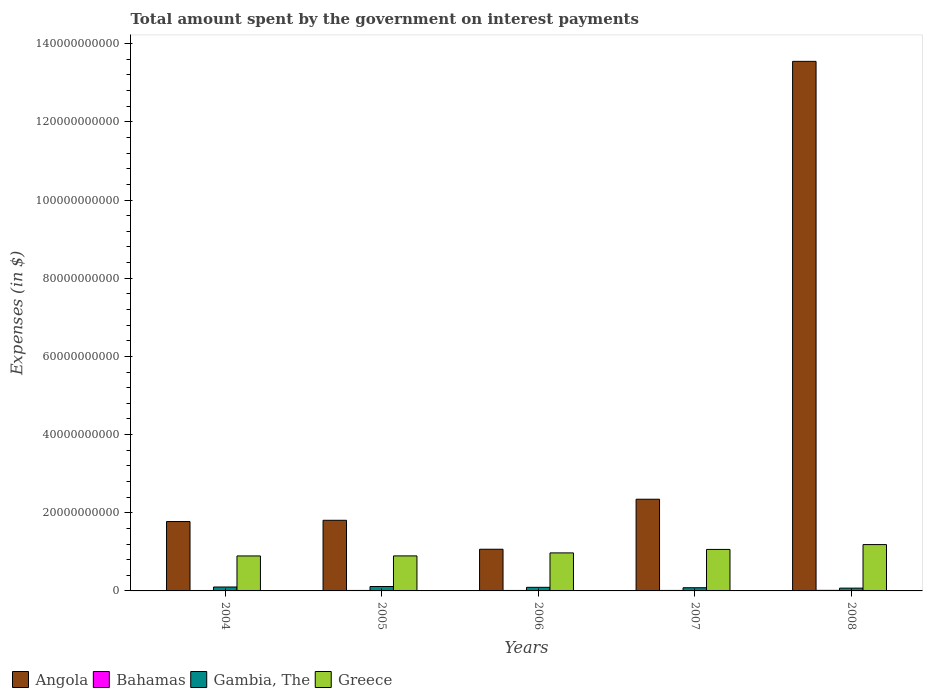How many different coloured bars are there?
Make the answer very short. 4. Are the number of bars per tick equal to the number of legend labels?
Give a very brief answer. Yes. Are the number of bars on each tick of the X-axis equal?
Keep it short and to the point. Yes. How many bars are there on the 2nd tick from the left?
Make the answer very short. 4. What is the amount spent on interest payments by the government in Angola in 2007?
Provide a succinct answer. 2.35e+1. Across all years, what is the maximum amount spent on interest payments by the government in Bahamas?
Your response must be concise. 1.43e+08. Across all years, what is the minimum amount spent on interest payments by the government in Greece?
Offer a very short reply. 8.95e+09. In which year was the amount spent on interest payments by the government in Gambia, The maximum?
Your answer should be very brief. 2005. What is the total amount spent on interest payments by the government in Greece in the graph?
Your response must be concise. 5.01e+1. What is the difference between the amount spent on interest payments by the government in Angola in 2006 and that in 2008?
Give a very brief answer. -1.25e+11. What is the difference between the amount spent on interest payments by the government in Gambia, The in 2008 and the amount spent on interest payments by the government in Greece in 2007?
Offer a terse response. -9.90e+09. What is the average amount spent on interest payments by the government in Bahamas per year?
Keep it short and to the point. 1.24e+08. In the year 2006, what is the difference between the amount spent on interest payments by the government in Gambia, The and amount spent on interest payments by the government in Greece?
Your response must be concise. -8.81e+09. In how many years, is the amount spent on interest payments by the government in Bahamas greater than 100000000000 $?
Provide a succinct answer. 0. What is the ratio of the amount spent on interest payments by the government in Bahamas in 2005 to that in 2006?
Your answer should be very brief. 1.04. Is the amount spent on interest payments by the government in Greece in 2004 less than that in 2005?
Your answer should be very brief. Yes. Is the difference between the amount spent on interest payments by the government in Gambia, The in 2005 and 2006 greater than the difference between the amount spent on interest payments by the government in Greece in 2005 and 2006?
Keep it short and to the point. Yes. What is the difference between the highest and the second highest amount spent on interest payments by the government in Gambia, The?
Make the answer very short. 1.28e+08. What is the difference between the highest and the lowest amount spent on interest payments by the government in Angola?
Ensure brevity in your answer.  1.25e+11. In how many years, is the amount spent on interest payments by the government in Greece greater than the average amount spent on interest payments by the government in Greece taken over all years?
Provide a succinct answer. 2. Is the sum of the amount spent on interest payments by the government in Bahamas in 2004 and 2006 greater than the maximum amount spent on interest payments by the government in Greece across all years?
Your answer should be very brief. No. Is it the case that in every year, the sum of the amount spent on interest payments by the government in Bahamas and amount spent on interest payments by the government in Greece is greater than the sum of amount spent on interest payments by the government in Gambia, The and amount spent on interest payments by the government in Angola?
Your answer should be very brief. No. What does the 2nd bar from the left in 2005 represents?
Give a very brief answer. Bahamas. What does the 1st bar from the right in 2005 represents?
Ensure brevity in your answer.  Greece. How many bars are there?
Provide a short and direct response. 20. Are all the bars in the graph horizontal?
Offer a terse response. No. What is the difference between two consecutive major ticks on the Y-axis?
Keep it short and to the point. 2.00e+1. Does the graph contain any zero values?
Provide a short and direct response. No. Does the graph contain grids?
Give a very brief answer. No. How many legend labels are there?
Your answer should be compact. 4. What is the title of the graph?
Offer a terse response. Total amount spent by the government on interest payments. Does "Ukraine" appear as one of the legend labels in the graph?
Keep it short and to the point. No. What is the label or title of the X-axis?
Your answer should be compact. Years. What is the label or title of the Y-axis?
Your answer should be very brief. Expenses (in $). What is the Expenses (in $) in Angola in 2004?
Provide a succinct answer. 1.78e+1. What is the Expenses (in $) in Bahamas in 2004?
Your response must be concise. 1.14e+08. What is the Expenses (in $) in Gambia, The in 2004?
Your response must be concise. 1.00e+09. What is the Expenses (in $) in Greece in 2004?
Ensure brevity in your answer.  8.95e+09. What is the Expenses (in $) of Angola in 2005?
Ensure brevity in your answer.  1.81e+1. What is the Expenses (in $) of Bahamas in 2005?
Offer a terse response. 1.21e+08. What is the Expenses (in $) in Gambia, The in 2005?
Your response must be concise. 1.13e+09. What is the Expenses (in $) of Greece in 2005?
Provide a succinct answer. 8.96e+09. What is the Expenses (in $) in Angola in 2006?
Your response must be concise. 1.07e+1. What is the Expenses (in $) in Bahamas in 2006?
Ensure brevity in your answer.  1.17e+08. What is the Expenses (in $) of Gambia, The in 2006?
Make the answer very short. 9.21e+08. What is the Expenses (in $) of Greece in 2006?
Your answer should be very brief. 9.73e+09. What is the Expenses (in $) in Angola in 2007?
Provide a succinct answer. 2.35e+1. What is the Expenses (in $) of Bahamas in 2007?
Provide a succinct answer. 1.27e+08. What is the Expenses (in $) in Gambia, The in 2007?
Your response must be concise. 8.15e+08. What is the Expenses (in $) in Greece in 2007?
Ensure brevity in your answer.  1.06e+1. What is the Expenses (in $) in Angola in 2008?
Give a very brief answer. 1.35e+11. What is the Expenses (in $) of Bahamas in 2008?
Ensure brevity in your answer.  1.43e+08. What is the Expenses (in $) in Gambia, The in 2008?
Provide a short and direct response. 7.13e+08. What is the Expenses (in $) in Greece in 2008?
Your answer should be very brief. 1.19e+1. Across all years, what is the maximum Expenses (in $) in Angola?
Your answer should be very brief. 1.35e+11. Across all years, what is the maximum Expenses (in $) of Bahamas?
Your response must be concise. 1.43e+08. Across all years, what is the maximum Expenses (in $) of Gambia, The?
Make the answer very short. 1.13e+09. Across all years, what is the maximum Expenses (in $) in Greece?
Give a very brief answer. 1.19e+1. Across all years, what is the minimum Expenses (in $) in Angola?
Your answer should be compact. 1.07e+1. Across all years, what is the minimum Expenses (in $) in Bahamas?
Make the answer very short. 1.14e+08. Across all years, what is the minimum Expenses (in $) of Gambia, The?
Keep it short and to the point. 7.13e+08. Across all years, what is the minimum Expenses (in $) of Greece?
Offer a very short reply. 8.95e+09. What is the total Expenses (in $) in Angola in the graph?
Offer a very short reply. 2.05e+11. What is the total Expenses (in $) in Bahamas in the graph?
Ensure brevity in your answer.  6.22e+08. What is the total Expenses (in $) in Gambia, The in the graph?
Offer a terse response. 4.58e+09. What is the total Expenses (in $) in Greece in the graph?
Your answer should be compact. 5.01e+1. What is the difference between the Expenses (in $) of Angola in 2004 and that in 2005?
Provide a succinct answer. -3.18e+08. What is the difference between the Expenses (in $) of Bahamas in 2004 and that in 2005?
Provide a short and direct response. -7.31e+06. What is the difference between the Expenses (in $) in Gambia, The in 2004 and that in 2005?
Keep it short and to the point. -1.28e+08. What is the difference between the Expenses (in $) of Greece in 2004 and that in 2005?
Provide a succinct answer. -1.20e+07. What is the difference between the Expenses (in $) of Angola in 2004 and that in 2006?
Provide a succinct answer. 7.09e+09. What is the difference between the Expenses (in $) of Bahamas in 2004 and that in 2006?
Provide a succinct answer. -2.63e+06. What is the difference between the Expenses (in $) in Gambia, The in 2004 and that in 2006?
Provide a succinct answer. 8.17e+07. What is the difference between the Expenses (in $) of Greece in 2004 and that in 2006?
Provide a succinct answer. -7.78e+08. What is the difference between the Expenses (in $) of Angola in 2004 and that in 2007?
Offer a very short reply. -5.71e+09. What is the difference between the Expenses (in $) in Bahamas in 2004 and that in 2007?
Give a very brief answer. -1.32e+07. What is the difference between the Expenses (in $) of Gambia, The in 2004 and that in 2007?
Your response must be concise. 1.88e+08. What is the difference between the Expenses (in $) in Greece in 2004 and that in 2007?
Provide a succinct answer. -1.66e+09. What is the difference between the Expenses (in $) in Angola in 2004 and that in 2008?
Provide a short and direct response. -1.18e+11. What is the difference between the Expenses (in $) of Bahamas in 2004 and that in 2008?
Your answer should be compact. -2.92e+07. What is the difference between the Expenses (in $) in Gambia, The in 2004 and that in 2008?
Your answer should be compact. 2.90e+08. What is the difference between the Expenses (in $) in Greece in 2004 and that in 2008?
Keep it short and to the point. -2.90e+09. What is the difference between the Expenses (in $) of Angola in 2005 and that in 2006?
Give a very brief answer. 7.40e+09. What is the difference between the Expenses (in $) in Bahamas in 2005 and that in 2006?
Offer a terse response. 4.67e+06. What is the difference between the Expenses (in $) of Gambia, The in 2005 and that in 2006?
Your response must be concise. 2.10e+08. What is the difference between the Expenses (in $) of Greece in 2005 and that in 2006?
Offer a terse response. -7.66e+08. What is the difference between the Expenses (in $) of Angola in 2005 and that in 2007?
Make the answer very short. -5.39e+09. What is the difference between the Expenses (in $) of Bahamas in 2005 and that in 2007?
Your answer should be compact. -5.92e+06. What is the difference between the Expenses (in $) of Gambia, The in 2005 and that in 2007?
Keep it short and to the point. 3.16e+08. What is the difference between the Expenses (in $) of Greece in 2005 and that in 2007?
Make the answer very short. -1.65e+09. What is the difference between the Expenses (in $) in Angola in 2005 and that in 2008?
Provide a short and direct response. -1.17e+11. What is the difference between the Expenses (in $) in Bahamas in 2005 and that in 2008?
Offer a terse response. -2.19e+07. What is the difference between the Expenses (in $) in Gambia, The in 2005 and that in 2008?
Offer a terse response. 4.18e+08. What is the difference between the Expenses (in $) of Greece in 2005 and that in 2008?
Provide a succinct answer. -2.89e+09. What is the difference between the Expenses (in $) in Angola in 2006 and that in 2007?
Ensure brevity in your answer.  -1.28e+1. What is the difference between the Expenses (in $) in Bahamas in 2006 and that in 2007?
Offer a very short reply. -1.06e+07. What is the difference between the Expenses (in $) of Gambia, The in 2006 and that in 2007?
Your answer should be very brief. 1.06e+08. What is the difference between the Expenses (in $) of Greece in 2006 and that in 2007?
Provide a succinct answer. -8.87e+08. What is the difference between the Expenses (in $) of Angola in 2006 and that in 2008?
Your answer should be compact. -1.25e+11. What is the difference between the Expenses (in $) in Bahamas in 2006 and that in 2008?
Your answer should be compact. -2.66e+07. What is the difference between the Expenses (in $) of Gambia, The in 2006 and that in 2008?
Your response must be concise. 2.08e+08. What is the difference between the Expenses (in $) in Greece in 2006 and that in 2008?
Your answer should be very brief. -2.13e+09. What is the difference between the Expenses (in $) of Angola in 2007 and that in 2008?
Your response must be concise. -1.12e+11. What is the difference between the Expenses (in $) of Bahamas in 2007 and that in 2008?
Provide a succinct answer. -1.60e+07. What is the difference between the Expenses (in $) in Gambia, The in 2007 and that in 2008?
Give a very brief answer. 1.02e+08. What is the difference between the Expenses (in $) of Greece in 2007 and that in 2008?
Give a very brief answer. -1.24e+09. What is the difference between the Expenses (in $) of Angola in 2004 and the Expenses (in $) of Bahamas in 2005?
Give a very brief answer. 1.76e+1. What is the difference between the Expenses (in $) of Angola in 2004 and the Expenses (in $) of Gambia, The in 2005?
Keep it short and to the point. 1.66e+1. What is the difference between the Expenses (in $) of Angola in 2004 and the Expenses (in $) of Greece in 2005?
Keep it short and to the point. 8.79e+09. What is the difference between the Expenses (in $) in Bahamas in 2004 and the Expenses (in $) in Gambia, The in 2005?
Give a very brief answer. -1.02e+09. What is the difference between the Expenses (in $) in Bahamas in 2004 and the Expenses (in $) in Greece in 2005?
Make the answer very short. -8.85e+09. What is the difference between the Expenses (in $) in Gambia, The in 2004 and the Expenses (in $) in Greece in 2005?
Offer a very short reply. -7.96e+09. What is the difference between the Expenses (in $) of Angola in 2004 and the Expenses (in $) of Bahamas in 2006?
Keep it short and to the point. 1.76e+1. What is the difference between the Expenses (in $) in Angola in 2004 and the Expenses (in $) in Gambia, The in 2006?
Keep it short and to the point. 1.68e+1. What is the difference between the Expenses (in $) in Angola in 2004 and the Expenses (in $) in Greece in 2006?
Offer a terse response. 8.02e+09. What is the difference between the Expenses (in $) in Bahamas in 2004 and the Expenses (in $) in Gambia, The in 2006?
Offer a terse response. -8.07e+08. What is the difference between the Expenses (in $) of Bahamas in 2004 and the Expenses (in $) of Greece in 2006?
Your response must be concise. -9.61e+09. What is the difference between the Expenses (in $) in Gambia, The in 2004 and the Expenses (in $) in Greece in 2006?
Your response must be concise. -8.72e+09. What is the difference between the Expenses (in $) in Angola in 2004 and the Expenses (in $) in Bahamas in 2007?
Your answer should be compact. 1.76e+1. What is the difference between the Expenses (in $) in Angola in 2004 and the Expenses (in $) in Gambia, The in 2007?
Your response must be concise. 1.69e+1. What is the difference between the Expenses (in $) in Angola in 2004 and the Expenses (in $) in Greece in 2007?
Your response must be concise. 7.14e+09. What is the difference between the Expenses (in $) in Bahamas in 2004 and the Expenses (in $) in Gambia, The in 2007?
Provide a short and direct response. -7.01e+08. What is the difference between the Expenses (in $) in Bahamas in 2004 and the Expenses (in $) in Greece in 2007?
Your answer should be compact. -1.05e+1. What is the difference between the Expenses (in $) in Gambia, The in 2004 and the Expenses (in $) in Greece in 2007?
Your response must be concise. -9.61e+09. What is the difference between the Expenses (in $) of Angola in 2004 and the Expenses (in $) of Bahamas in 2008?
Make the answer very short. 1.76e+1. What is the difference between the Expenses (in $) of Angola in 2004 and the Expenses (in $) of Gambia, The in 2008?
Give a very brief answer. 1.70e+1. What is the difference between the Expenses (in $) in Angola in 2004 and the Expenses (in $) in Greece in 2008?
Keep it short and to the point. 5.90e+09. What is the difference between the Expenses (in $) in Bahamas in 2004 and the Expenses (in $) in Gambia, The in 2008?
Provide a succinct answer. -5.99e+08. What is the difference between the Expenses (in $) in Bahamas in 2004 and the Expenses (in $) in Greece in 2008?
Offer a very short reply. -1.17e+1. What is the difference between the Expenses (in $) of Gambia, The in 2004 and the Expenses (in $) of Greece in 2008?
Offer a very short reply. -1.09e+1. What is the difference between the Expenses (in $) in Angola in 2005 and the Expenses (in $) in Bahamas in 2006?
Make the answer very short. 1.80e+1. What is the difference between the Expenses (in $) of Angola in 2005 and the Expenses (in $) of Gambia, The in 2006?
Your response must be concise. 1.71e+1. What is the difference between the Expenses (in $) in Angola in 2005 and the Expenses (in $) in Greece in 2006?
Give a very brief answer. 8.34e+09. What is the difference between the Expenses (in $) in Bahamas in 2005 and the Expenses (in $) in Gambia, The in 2006?
Your answer should be very brief. -8.00e+08. What is the difference between the Expenses (in $) in Bahamas in 2005 and the Expenses (in $) in Greece in 2006?
Make the answer very short. -9.61e+09. What is the difference between the Expenses (in $) of Gambia, The in 2005 and the Expenses (in $) of Greece in 2006?
Your response must be concise. -8.60e+09. What is the difference between the Expenses (in $) in Angola in 2005 and the Expenses (in $) in Bahamas in 2007?
Your answer should be compact. 1.79e+1. What is the difference between the Expenses (in $) of Angola in 2005 and the Expenses (in $) of Gambia, The in 2007?
Offer a very short reply. 1.73e+1. What is the difference between the Expenses (in $) of Angola in 2005 and the Expenses (in $) of Greece in 2007?
Offer a terse response. 7.46e+09. What is the difference between the Expenses (in $) in Bahamas in 2005 and the Expenses (in $) in Gambia, The in 2007?
Make the answer very short. -6.94e+08. What is the difference between the Expenses (in $) of Bahamas in 2005 and the Expenses (in $) of Greece in 2007?
Ensure brevity in your answer.  -1.05e+1. What is the difference between the Expenses (in $) in Gambia, The in 2005 and the Expenses (in $) in Greece in 2007?
Your answer should be compact. -9.48e+09. What is the difference between the Expenses (in $) in Angola in 2005 and the Expenses (in $) in Bahamas in 2008?
Provide a succinct answer. 1.79e+1. What is the difference between the Expenses (in $) in Angola in 2005 and the Expenses (in $) in Gambia, The in 2008?
Your answer should be very brief. 1.74e+1. What is the difference between the Expenses (in $) in Angola in 2005 and the Expenses (in $) in Greece in 2008?
Make the answer very short. 6.22e+09. What is the difference between the Expenses (in $) in Bahamas in 2005 and the Expenses (in $) in Gambia, The in 2008?
Provide a short and direct response. -5.92e+08. What is the difference between the Expenses (in $) in Bahamas in 2005 and the Expenses (in $) in Greece in 2008?
Provide a short and direct response. -1.17e+1. What is the difference between the Expenses (in $) of Gambia, The in 2005 and the Expenses (in $) of Greece in 2008?
Provide a succinct answer. -1.07e+1. What is the difference between the Expenses (in $) of Angola in 2006 and the Expenses (in $) of Bahamas in 2007?
Your answer should be very brief. 1.05e+1. What is the difference between the Expenses (in $) of Angola in 2006 and the Expenses (in $) of Gambia, The in 2007?
Provide a short and direct response. 9.85e+09. What is the difference between the Expenses (in $) of Angola in 2006 and the Expenses (in $) of Greece in 2007?
Keep it short and to the point. 5.04e+07. What is the difference between the Expenses (in $) in Bahamas in 2006 and the Expenses (in $) in Gambia, The in 2007?
Make the answer very short. -6.98e+08. What is the difference between the Expenses (in $) of Bahamas in 2006 and the Expenses (in $) of Greece in 2007?
Your answer should be very brief. -1.05e+1. What is the difference between the Expenses (in $) of Gambia, The in 2006 and the Expenses (in $) of Greece in 2007?
Keep it short and to the point. -9.69e+09. What is the difference between the Expenses (in $) of Angola in 2006 and the Expenses (in $) of Bahamas in 2008?
Give a very brief answer. 1.05e+1. What is the difference between the Expenses (in $) of Angola in 2006 and the Expenses (in $) of Gambia, The in 2008?
Provide a short and direct response. 9.95e+09. What is the difference between the Expenses (in $) of Angola in 2006 and the Expenses (in $) of Greece in 2008?
Offer a very short reply. -1.19e+09. What is the difference between the Expenses (in $) of Bahamas in 2006 and the Expenses (in $) of Gambia, The in 2008?
Make the answer very short. -5.97e+08. What is the difference between the Expenses (in $) of Bahamas in 2006 and the Expenses (in $) of Greece in 2008?
Keep it short and to the point. -1.17e+1. What is the difference between the Expenses (in $) of Gambia, The in 2006 and the Expenses (in $) of Greece in 2008?
Your answer should be very brief. -1.09e+1. What is the difference between the Expenses (in $) of Angola in 2007 and the Expenses (in $) of Bahamas in 2008?
Give a very brief answer. 2.33e+1. What is the difference between the Expenses (in $) in Angola in 2007 and the Expenses (in $) in Gambia, The in 2008?
Give a very brief answer. 2.27e+1. What is the difference between the Expenses (in $) in Angola in 2007 and the Expenses (in $) in Greece in 2008?
Give a very brief answer. 1.16e+1. What is the difference between the Expenses (in $) in Bahamas in 2007 and the Expenses (in $) in Gambia, The in 2008?
Your answer should be very brief. -5.86e+08. What is the difference between the Expenses (in $) of Bahamas in 2007 and the Expenses (in $) of Greece in 2008?
Keep it short and to the point. -1.17e+1. What is the difference between the Expenses (in $) of Gambia, The in 2007 and the Expenses (in $) of Greece in 2008?
Your answer should be compact. -1.10e+1. What is the average Expenses (in $) of Angola per year?
Your answer should be compact. 4.11e+1. What is the average Expenses (in $) of Bahamas per year?
Make the answer very short. 1.24e+08. What is the average Expenses (in $) of Gambia, The per year?
Your answer should be very brief. 9.17e+08. What is the average Expenses (in $) of Greece per year?
Provide a short and direct response. 1.00e+1. In the year 2004, what is the difference between the Expenses (in $) of Angola and Expenses (in $) of Bahamas?
Keep it short and to the point. 1.76e+1. In the year 2004, what is the difference between the Expenses (in $) in Angola and Expenses (in $) in Gambia, The?
Provide a succinct answer. 1.67e+1. In the year 2004, what is the difference between the Expenses (in $) in Angola and Expenses (in $) in Greece?
Keep it short and to the point. 8.80e+09. In the year 2004, what is the difference between the Expenses (in $) in Bahamas and Expenses (in $) in Gambia, The?
Give a very brief answer. -8.89e+08. In the year 2004, what is the difference between the Expenses (in $) of Bahamas and Expenses (in $) of Greece?
Make the answer very short. -8.84e+09. In the year 2004, what is the difference between the Expenses (in $) of Gambia, The and Expenses (in $) of Greece?
Ensure brevity in your answer.  -7.95e+09. In the year 2005, what is the difference between the Expenses (in $) of Angola and Expenses (in $) of Bahamas?
Provide a succinct answer. 1.79e+1. In the year 2005, what is the difference between the Expenses (in $) of Angola and Expenses (in $) of Gambia, The?
Offer a very short reply. 1.69e+1. In the year 2005, what is the difference between the Expenses (in $) in Angola and Expenses (in $) in Greece?
Your answer should be very brief. 9.11e+09. In the year 2005, what is the difference between the Expenses (in $) of Bahamas and Expenses (in $) of Gambia, The?
Your answer should be compact. -1.01e+09. In the year 2005, what is the difference between the Expenses (in $) in Bahamas and Expenses (in $) in Greece?
Give a very brief answer. -8.84e+09. In the year 2005, what is the difference between the Expenses (in $) of Gambia, The and Expenses (in $) of Greece?
Your answer should be very brief. -7.83e+09. In the year 2006, what is the difference between the Expenses (in $) of Angola and Expenses (in $) of Bahamas?
Provide a short and direct response. 1.05e+1. In the year 2006, what is the difference between the Expenses (in $) in Angola and Expenses (in $) in Gambia, The?
Your answer should be very brief. 9.74e+09. In the year 2006, what is the difference between the Expenses (in $) of Angola and Expenses (in $) of Greece?
Provide a short and direct response. 9.37e+08. In the year 2006, what is the difference between the Expenses (in $) in Bahamas and Expenses (in $) in Gambia, The?
Ensure brevity in your answer.  -8.05e+08. In the year 2006, what is the difference between the Expenses (in $) in Bahamas and Expenses (in $) in Greece?
Give a very brief answer. -9.61e+09. In the year 2006, what is the difference between the Expenses (in $) in Gambia, The and Expenses (in $) in Greece?
Offer a very short reply. -8.81e+09. In the year 2007, what is the difference between the Expenses (in $) of Angola and Expenses (in $) of Bahamas?
Your answer should be compact. 2.33e+1. In the year 2007, what is the difference between the Expenses (in $) in Angola and Expenses (in $) in Gambia, The?
Your response must be concise. 2.26e+1. In the year 2007, what is the difference between the Expenses (in $) in Angola and Expenses (in $) in Greece?
Your answer should be very brief. 1.28e+1. In the year 2007, what is the difference between the Expenses (in $) of Bahamas and Expenses (in $) of Gambia, The?
Provide a short and direct response. -6.88e+08. In the year 2007, what is the difference between the Expenses (in $) in Bahamas and Expenses (in $) in Greece?
Offer a very short reply. -1.05e+1. In the year 2007, what is the difference between the Expenses (in $) of Gambia, The and Expenses (in $) of Greece?
Make the answer very short. -9.80e+09. In the year 2008, what is the difference between the Expenses (in $) in Angola and Expenses (in $) in Bahamas?
Provide a short and direct response. 1.35e+11. In the year 2008, what is the difference between the Expenses (in $) of Angola and Expenses (in $) of Gambia, The?
Your response must be concise. 1.35e+11. In the year 2008, what is the difference between the Expenses (in $) of Angola and Expenses (in $) of Greece?
Your response must be concise. 1.24e+11. In the year 2008, what is the difference between the Expenses (in $) in Bahamas and Expenses (in $) in Gambia, The?
Your answer should be compact. -5.70e+08. In the year 2008, what is the difference between the Expenses (in $) in Bahamas and Expenses (in $) in Greece?
Keep it short and to the point. -1.17e+1. In the year 2008, what is the difference between the Expenses (in $) of Gambia, The and Expenses (in $) of Greece?
Give a very brief answer. -1.11e+1. What is the ratio of the Expenses (in $) of Angola in 2004 to that in 2005?
Your response must be concise. 0.98. What is the ratio of the Expenses (in $) of Bahamas in 2004 to that in 2005?
Your answer should be very brief. 0.94. What is the ratio of the Expenses (in $) of Gambia, The in 2004 to that in 2005?
Offer a very short reply. 0.89. What is the ratio of the Expenses (in $) in Greece in 2004 to that in 2005?
Provide a short and direct response. 1. What is the ratio of the Expenses (in $) of Angola in 2004 to that in 2006?
Your response must be concise. 1.66. What is the ratio of the Expenses (in $) in Bahamas in 2004 to that in 2006?
Keep it short and to the point. 0.98. What is the ratio of the Expenses (in $) of Gambia, The in 2004 to that in 2006?
Offer a terse response. 1.09. What is the ratio of the Expenses (in $) of Angola in 2004 to that in 2007?
Give a very brief answer. 0.76. What is the ratio of the Expenses (in $) in Bahamas in 2004 to that in 2007?
Make the answer very short. 0.9. What is the ratio of the Expenses (in $) of Gambia, The in 2004 to that in 2007?
Ensure brevity in your answer.  1.23. What is the ratio of the Expenses (in $) of Greece in 2004 to that in 2007?
Make the answer very short. 0.84. What is the ratio of the Expenses (in $) of Angola in 2004 to that in 2008?
Make the answer very short. 0.13. What is the ratio of the Expenses (in $) of Bahamas in 2004 to that in 2008?
Provide a succinct answer. 0.8. What is the ratio of the Expenses (in $) of Gambia, The in 2004 to that in 2008?
Your answer should be very brief. 1.41. What is the ratio of the Expenses (in $) of Greece in 2004 to that in 2008?
Your response must be concise. 0.75. What is the ratio of the Expenses (in $) of Angola in 2005 to that in 2006?
Give a very brief answer. 1.69. What is the ratio of the Expenses (in $) in Bahamas in 2005 to that in 2006?
Your answer should be compact. 1.04. What is the ratio of the Expenses (in $) in Gambia, The in 2005 to that in 2006?
Give a very brief answer. 1.23. What is the ratio of the Expenses (in $) in Greece in 2005 to that in 2006?
Keep it short and to the point. 0.92. What is the ratio of the Expenses (in $) in Angola in 2005 to that in 2007?
Make the answer very short. 0.77. What is the ratio of the Expenses (in $) in Bahamas in 2005 to that in 2007?
Give a very brief answer. 0.95. What is the ratio of the Expenses (in $) of Gambia, The in 2005 to that in 2007?
Your answer should be compact. 1.39. What is the ratio of the Expenses (in $) of Greece in 2005 to that in 2007?
Provide a short and direct response. 0.84. What is the ratio of the Expenses (in $) in Angola in 2005 to that in 2008?
Ensure brevity in your answer.  0.13. What is the ratio of the Expenses (in $) of Bahamas in 2005 to that in 2008?
Make the answer very short. 0.85. What is the ratio of the Expenses (in $) in Gambia, The in 2005 to that in 2008?
Ensure brevity in your answer.  1.59. What is the ratio of the Expenses (in $) in Greece in 2005 to that in 2008?
Give a very brief answer. 0.76. What is the ratio of the Expenses (in $) in Angola in 2006 to that in 2007?
Ensure brevity in your answer.  0.45. What is the ratio of the Expenses (in $) of Gambia, The in 2006 to that in 2007?
Offer a very short reply. 1.13. What is the ratio of the Expenses (in $) in Greece in 2006 to that in 2007?
Your answer should be compact. 0.92. What is the ratio of the Expenses (in $) in Angola in 2006 to that in 2008?
Offer a terse response. 0.08. What is the ratio of the Expenses (in $) of Bahamas in 2006 to that in 2008?
Provide a short and direct response. 0.81. What is the ratio of the Expenses (in $) of Gambia, The in 2006 to that in 2008?
Make the answer very short. 1.29. What is the ratio of the Expenses (in $) of Greece in 2006 to that in 2008?
Keep it short and to the point. 0.82. What is the ratio of the Expenses (in $) in Angola in 2007 to that in 2008?
Make the answer very short. 0.17. What is the ratio of the Expenses (in $) of Bahamas in 2007 to that in 2008?
Offer a terse response. 0.89. What is the ratio of the Expenses (in $) of Gambia, The in 2007 to that in 2008?
Offer a terse response. 1.14. What is the ratio of the Expenses (in $) in Greece in 2007 to that in 2008?
Provide a short and direct response. 0.9. What is the difference between the highest and the second highest Expenses (in $) in Angola?
Provide a succinct answer. 1.12e+11. What is the difference between the highest and the second highest Expenses (in $) of Bahamas?
Ensure brevity in your answer.  1.60e+07. What is the difference between the highest and the second highest Expenses (in $) of Gambia, The?
Ensure brevity in your answer.  1.28e+08. What is the difference between the highest and the second highest Expenses (in $) of Greece?
Your response must be concise. 1.24e+09. What is the difference between the highest and the lowest Expenses (in $) in Angola?
Ensure brevity in your answer.  1.25e+11. What is the difference between the highest and the lowest Expenses (in $) in Bahamas?
Keep it short and to the point. 2.92e+07. What is the difference between the highest and the lowest Expenses (in $) in Gambia, The?
Provide a succinct answer. 4.18e+08. What is the difference between the highest and the lowest Expenses (in $) of Greece?
Your response must be concise. 2.90e+09. 